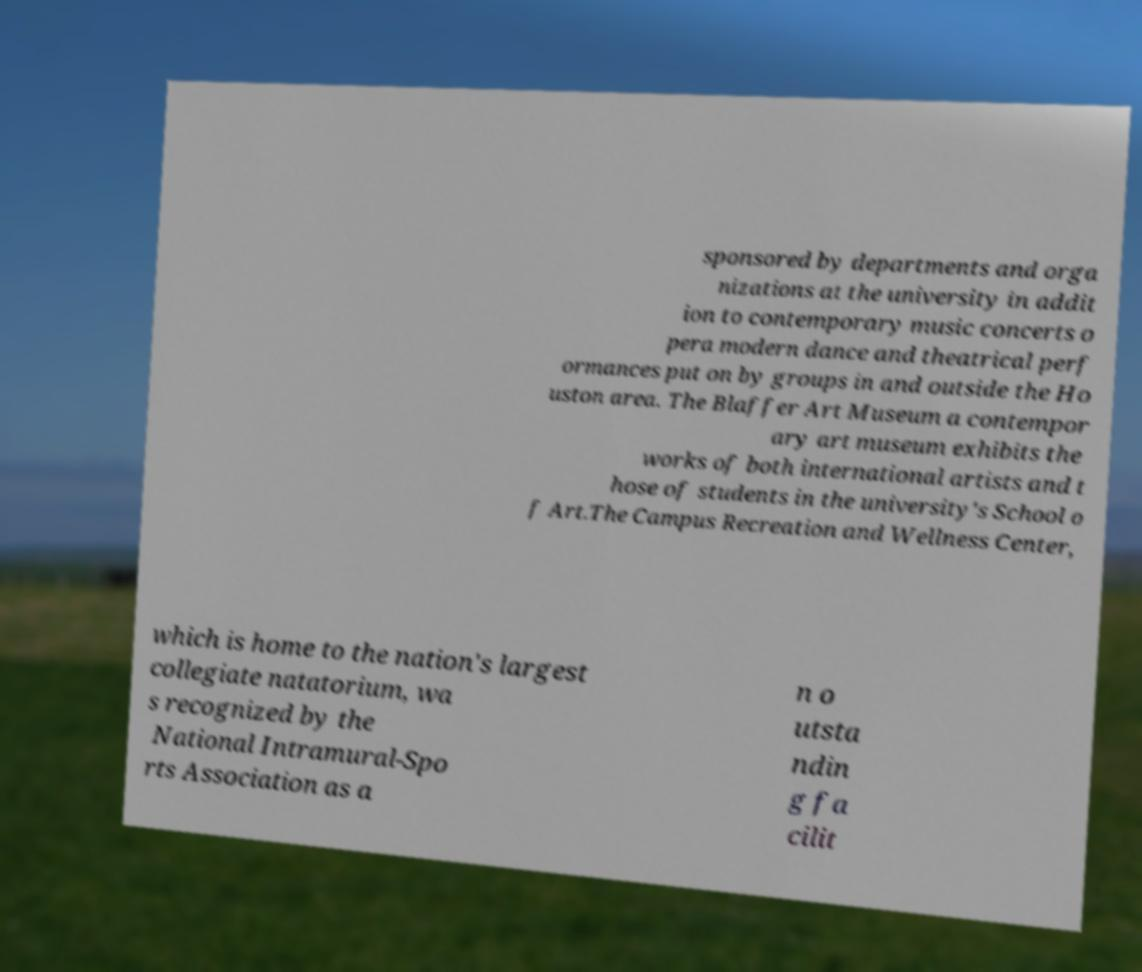For documentation purposes, I need the text within this image transcribed. Could you provide that? sponsored by departments and orga nizations at the university in addit ion to contemporary music concerts o pera modern dance and theatrical perf ormances put on by groups in and outside the Ho uston area. The Blaffer Art Museum a contempor ary art museum exhibits the works of both international artists and t hose of students in the university's School o f Art.The Campus Recreation and Wellness Center, which is home to the nation's largest collegiate natatorium, wa s recognized by the National Intramural-Spo rts Association as a n o utsta ndin g fa cilit 